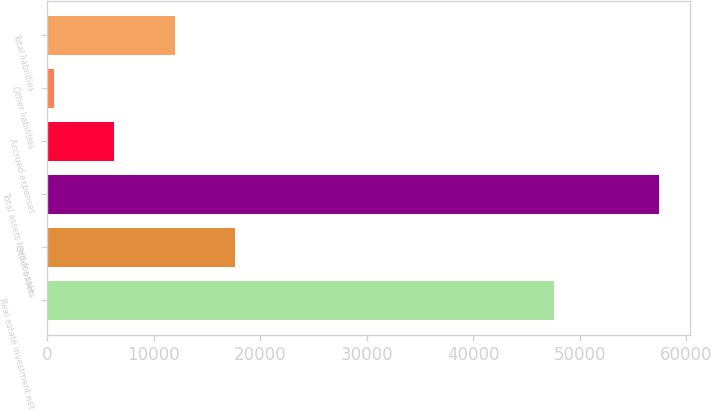<chart> <loc_0><loc_0><loc_500><loc_500><bar_chart><fcel>Real estate investment net<fcel>Other assets<fcel>Total assets held-for-sale<fcel>Accrued expenses<fcel>Other liabilities<fcel>Total liabilities<nl><fcel>47592<fcel>17655.6<fcel>57466<fcel>6281.2<fcel>594<fcel>11968.4<nl></chart> 